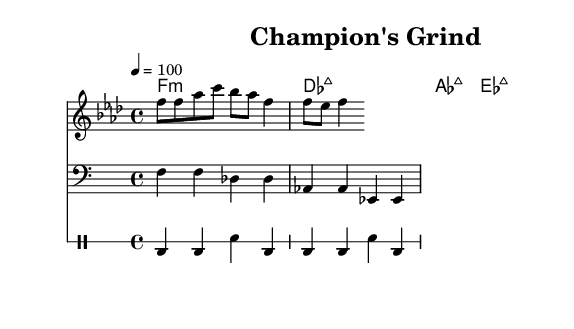What key is this piece in? The key signature shown at the beginning of the staff displays a B-flat and E-flat, which indicates that the piece is in F minor.
Answer: F minor What is the time signature of this piece? The time signature is located after the key signature, indicated by the "4/4" notation, meaning there are four beats in a measure and the quarter note gets one beat.
Answer: 4/4 What is the tempo marking for this composition? The tempo is indicated at the start with "4 = 100," which means that the quarter note is set to a speed of 100 beats per minute.
Answer: 100 How many measures are presented in the drum part? By analyzing the drum notation, it contains two distinct groups of four beats, adding up to a total of eight beats, or two measures of 4/4 time.
Answer: 2 measures What chord progression appears in the harmonies? The chords listed sequentially in the chord names indicate the progression is: F minor, D-flat major, A-flat major, and E-flat major.
Answer: F minor, D-flat major, A-flat major, E-flat major What clef is used for the bass line? The bass line notation starts with a specific symbol called the bass clef, which is used for lower pitches.
Answer: Bass clef 